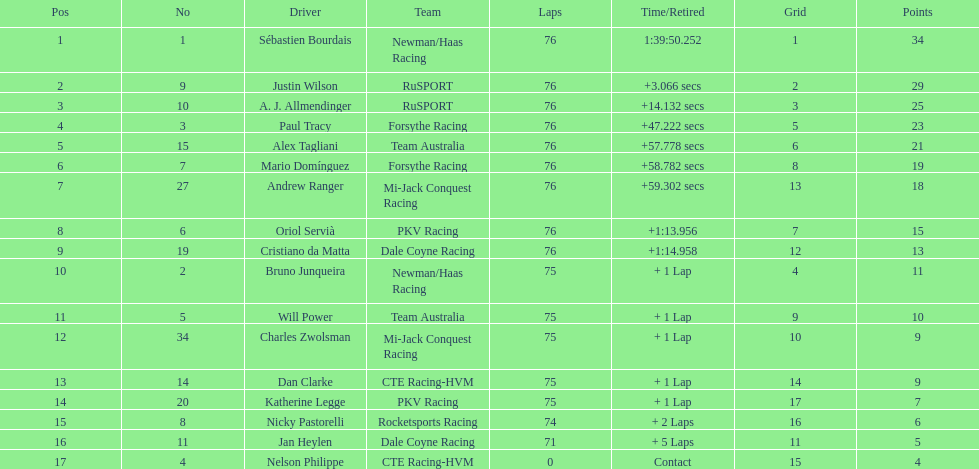I'm looking to parse the entire table for insights. Could you assist me with that? {'header': ['Pos', 'No', 'Driver', 'Team', 'Laps', 'Time/Retired', 'Grid', 'Points'], 'rows': [['1', '1', 'Sébastien Bourdais', 'Newman/Haas Racing', '76', '1:39:50.252', '1', '34'], ['2', '9', 'Justin Wilson', 'RuSPORT', '76', '+3.066 secs', '2', '29'], ['3', '10', 'A. J. Allmendinger', 'RuSPORT', '76', '+14.132 secs', '3', '25'], ['4', '3', 'Paul Tracy', 'Forsythe Racing', '76', '+47.222 secs', '5', '23'], ['5', '15', 'Alex Tagliani', 'Team Australia', '76', '+57.778 secs', '6', '21'], ['6', '7', 'Mario Domínguez', 'Forsythe Racing', '76', '+58.782 secs', '8', '19'], ['7', '27', 'Andrew Ranger', 'Mi-Jack Conquest Racing', '76', '+59.302 secs', '13', '18'], ['8', '6', 'Oriol Servià', 'PKV Racing', '76', '+1:13.956', '7', '15'], ['9', '19', 'Cristiano da Matta', 'Dale Coyne Racing', '76', '+1:14.958', '12', '13'], ['10', '2', 'Bruno Junqueira', 'Newman/Haas Racing', '75', '+ 1 Lap', '4', '11'], ['11', '5', 'Will Power', 'Team Australia', '75', '+ 1 Lap', '9', '10'], ['12', '34', 'Charles Zwolsman', 'Mi-Jack Conquest Racing', '75', '+ 1 Lap', '10', '9'], ['13', '14', 'Dan Clarke', 'CTE Racing-HVM', '75', '+ 1 Lap', '14', '9'], ['14', '20', 'Katherine Legge', 'PKV Racing', '75', '+ 1 Lap', '17', '7'], ['15', '8', 'Nicky Pastorelli', 'Rocketsports Racing', '74', '+ 2 Laps', '16', '6'], ['16', '11', 'Jan Heylen', 'Dale Coyne Racing', '71', '+ 5 Laps', '11', '5'], ['17', '4', 'Nelson Philippe', 'CTE Racing-HVM', '0', 'Contact', '15', '4']]} Who did charles zwolsman accumulate an equal number of points as? Dan Clarke. 